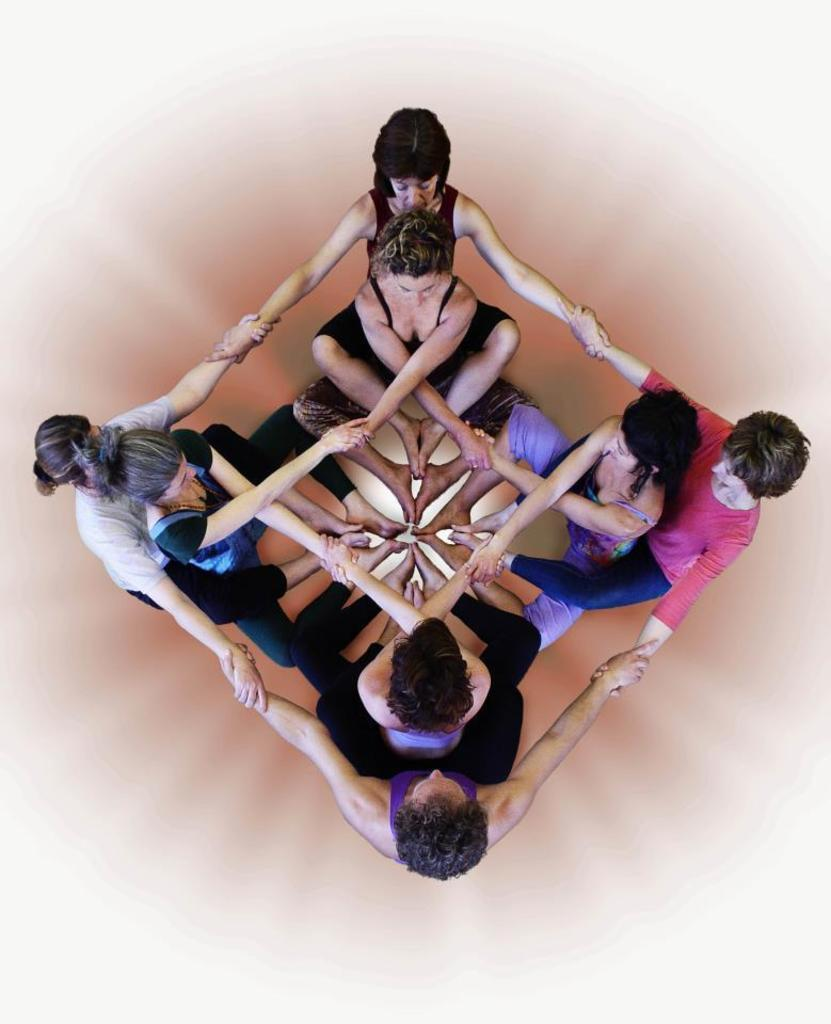How many people are present in the image? There are eight people in the image. What are the people doing with their bodies in the image? The people are holding their hands and legs together. What color is the background of the image? The background of the image is white. What type of bag can be seen hanging from the bell in the image? There is no bag or bell present in the image. What is the starting point of the activity depicted in the image? The image does not depict an activity with a specific starting point. 